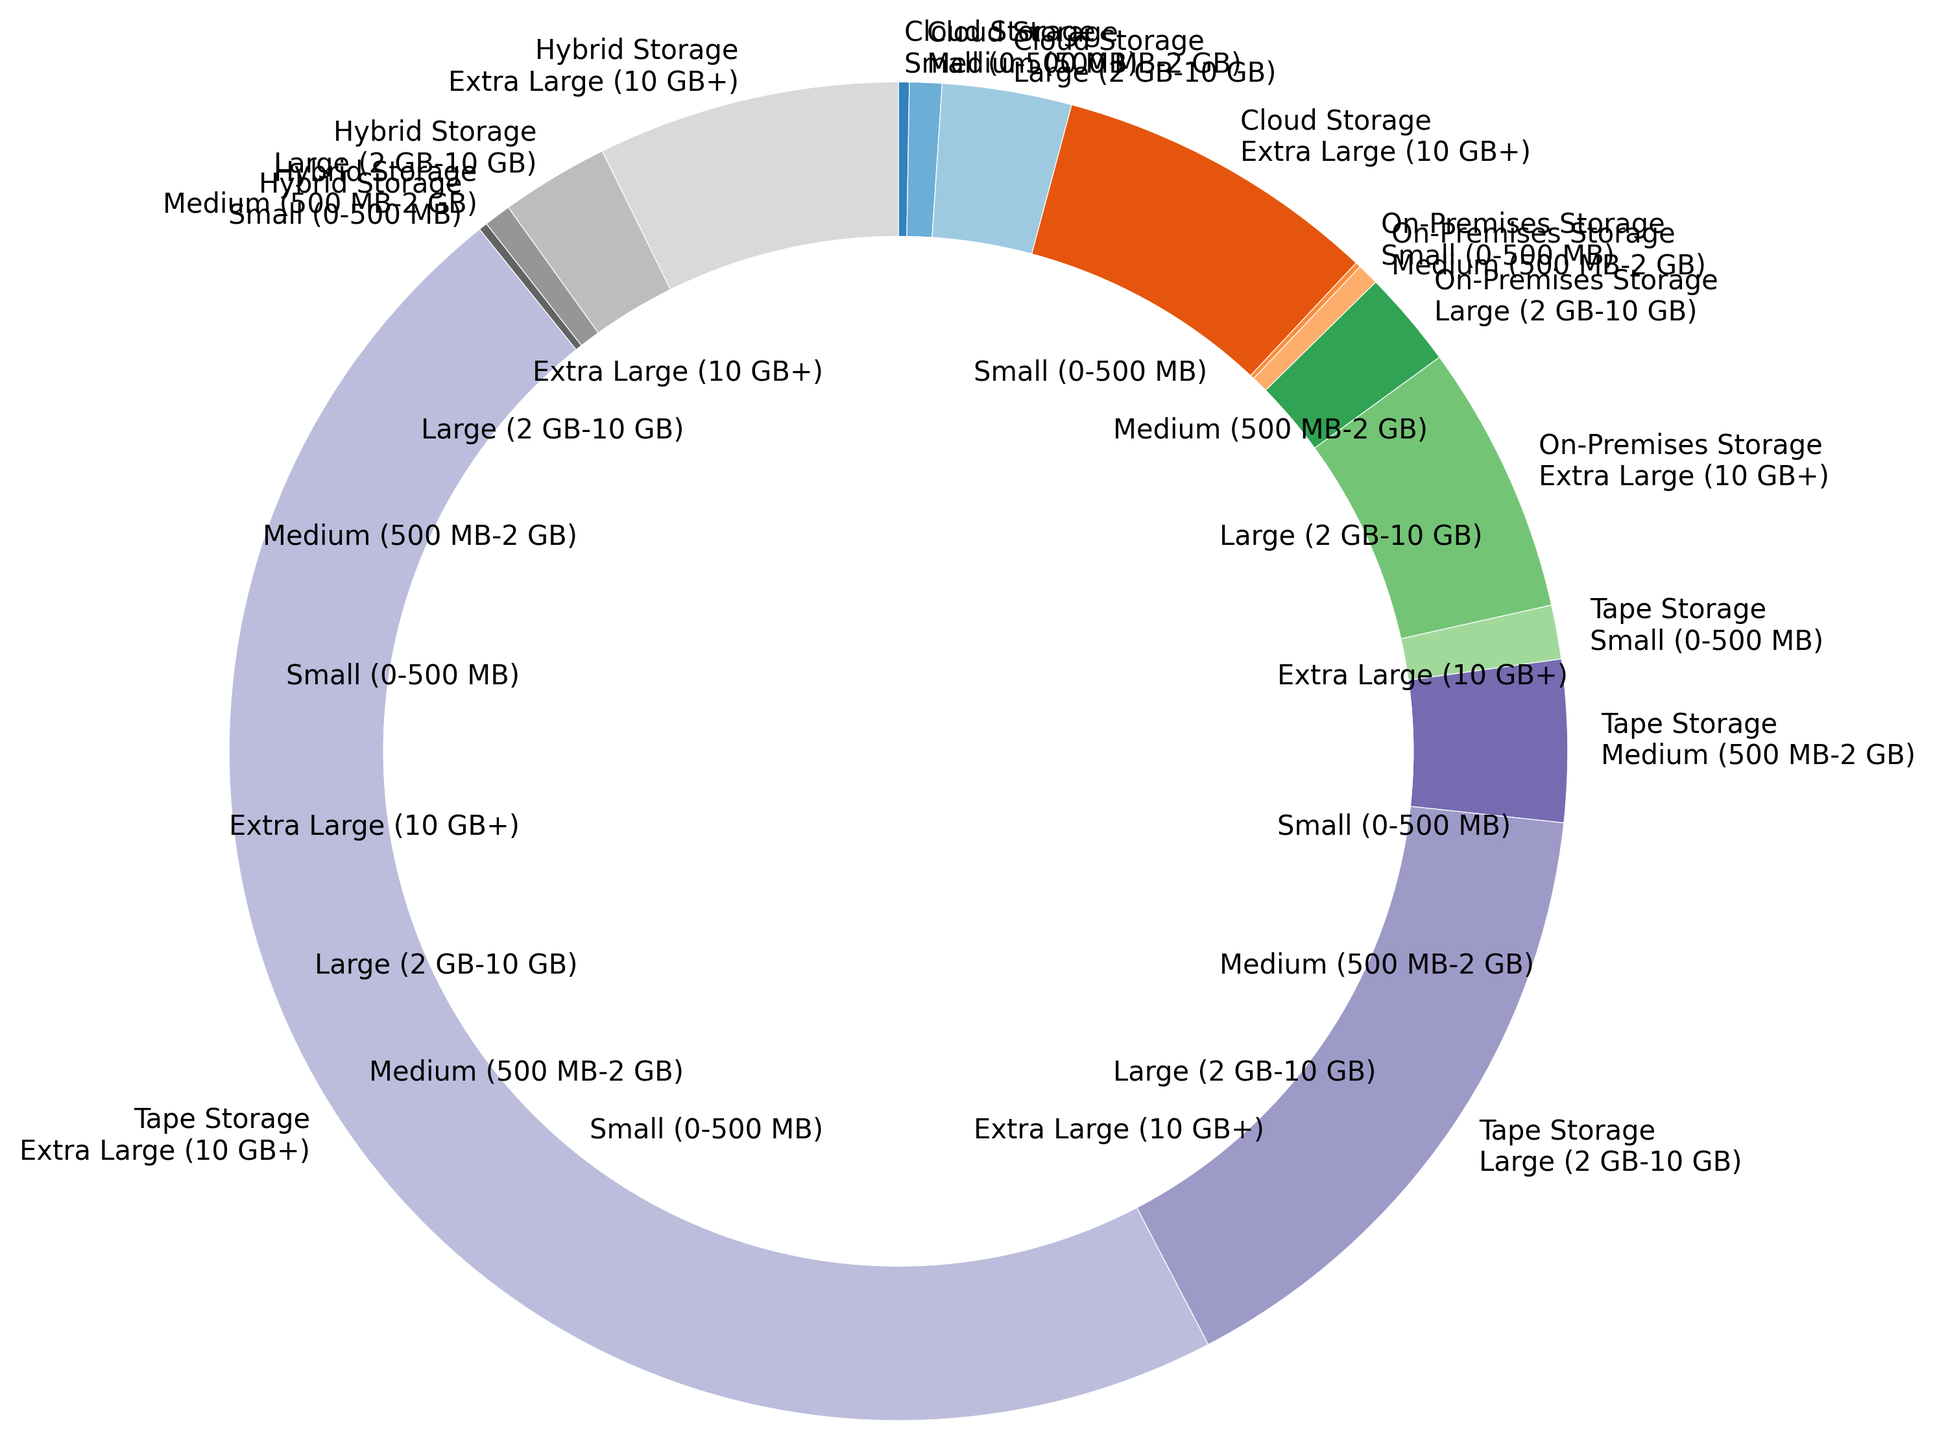Which storage type has the fastest retrieval time for small data sizes? To identify the fastest retrieval time for small data sizes, look for the smallest segment in the inner ring labeled "Small (0-500 MB)." The smallest segment corresponds to the "On-Premises Storage" system, which has a retrieval time of 5 seconds.
Answer: On-Premises Storage Which storage type shows the greatest increase in retrieval time between small and extra-large data sizes? Compare the difference in retrieval times between small and extra-large data sizes for each storage type. Tape Storage has the largest increase, from 50 seconds to 1800 seconds, resulting in a difference of 1750 seconds.
Answer: Tape Storage Which system has the most uniform retrieval times across different data size categories? To find the most uniform retrieval times, look for the system with the least variation in pie segment sizes. On-Premises Storage has the closest segment sizes among small, medium, large, and extra-large categories, indicating relatively uniform retrieval times compared to other systems.
Answer: On-Premises Storage How do retrieval times for large data sizes compare between Cloud Storage and Hybrid Storage? Locate the pie segments for "Large (2 GB-10 GB)" in both Cloud Storage and Hybrid Storage. The segment for Cloud Storage indicates a retrieval time of 120 seconds, while for Hybrid Storage, it is 100 seconds. Hybrid Storage has a faster retrieval time.
Answer: Hybrid Storage Which storage type is the slowest for medium-sized data retrieval, and how long does it take? Find the inner ring segments labeled "Medium (500 MB-2 GB)" and compare the retrieval times across systems. The largest segment for the medium category corresponds to Tape Storage, with a retrieval time of 150 seconds.
Answer: Tape Storage, 150 seconds How does the retrieval time for On-Premises Storage of extra-large data compare to the Hybrid Storage for the same data size? Check the outer ring for "Extra Large (10 GB+)" segments to compare On-Premises Storage and Hybrid Storage. On-Premises Storage takes 250 seconds, whereas Hybrid Storage takes 280 seconds. Thus, On-Premises Storage is faster.
Answer: On-Premises Storage is faster Which data size category in Cloud Storage has the longest retrieval time? Examine the "Cloud Storage" segments and identify the largest segment. The "Extra Large (10 GB+)" category is the largest, with a retrieval time of 300 seconds, making it the slowest for Cloud Storage.
Answer: Extra Large (10 GB+) What is the combined retrieval time for Tape Storage for small and medium data sizes? Add the retrieval times for "Small (0-500 MB)" and "Medium (500 MB-2 GB)" categories in Tape Storage. The retrieval times are 50 seconds and 150 seconds, respectively, resulting in a total of 50 + 150 = 200 seconds.
Answer: 200 seconds Which storage type has a retrieval time that is less than half of Tape Storage's retrieval time for large data sizes? Tape Storage's retrieval time for "Large (2 GB-10 GB)" is 600 seconds. Half of this time is 300 seconds. The storage type with a retrieval time less than 300 seconds is Cloud Storage (120 seconds), On-Premises Storage (90 seconds), and Hybrid Storage (100 seconds). They all meet the criteria.
Answer: Cloud Storage, On-Premises Storage, Hybrid Storage 